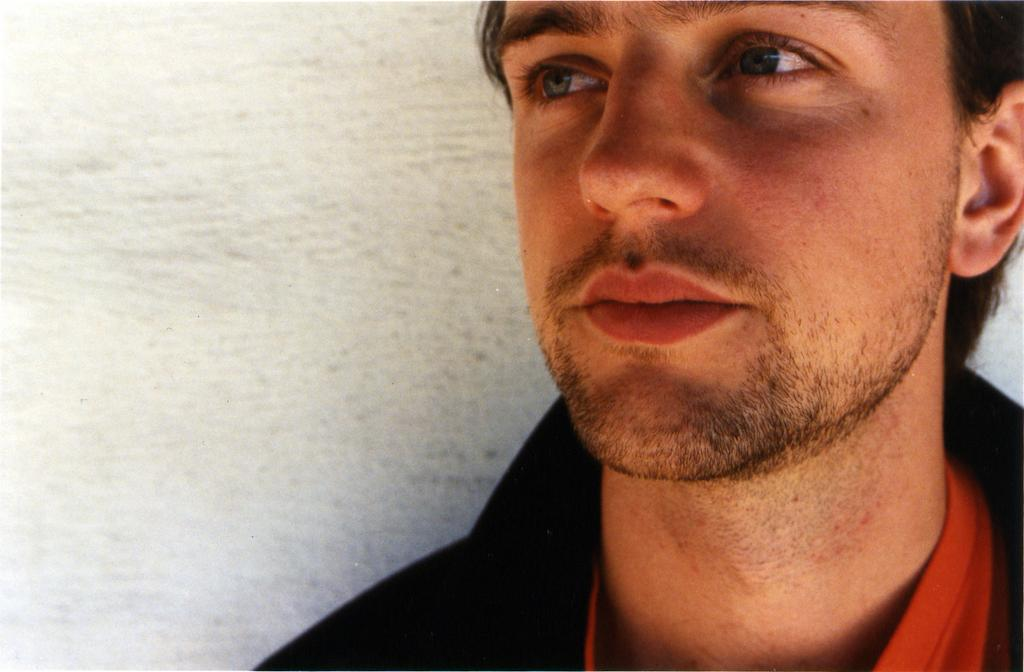What type of clothing are the men wearing in the image? The men are wearing black jackets and red T-shirts in the image. What can be seen behind the men in the image? The men are standing beside a wall in the image. What type of shop can be seen in the image? There is no shop visible in the image; it only shows men wearing black jackets and red T-shirts standing beside a wall. 